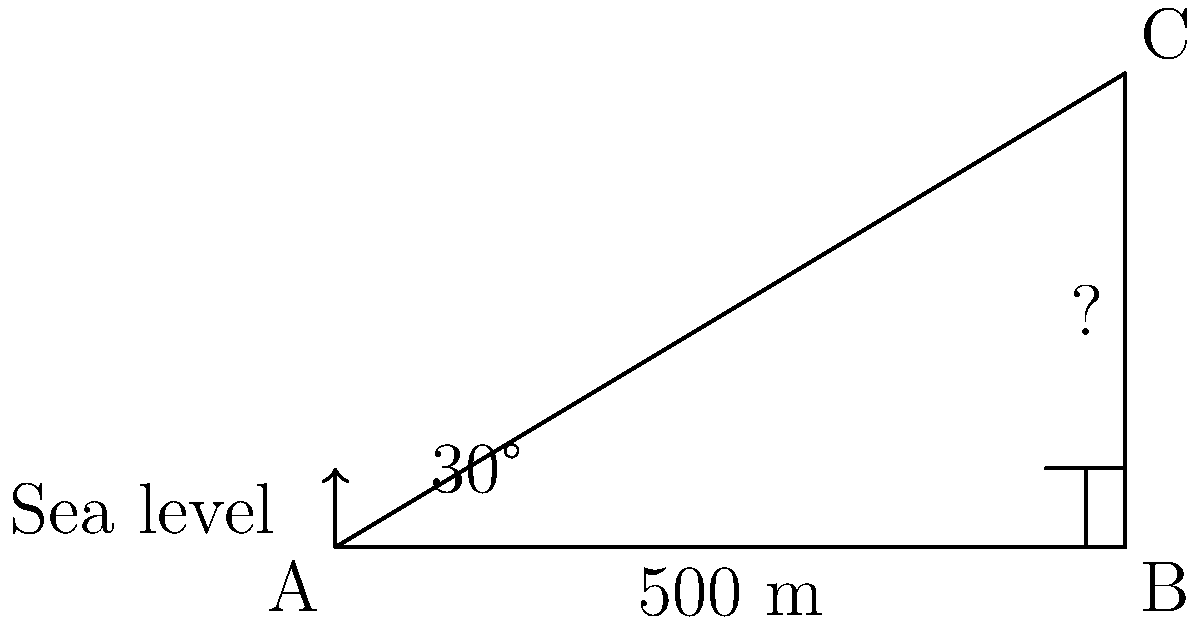As part of your lupus journey, you decide to challenge yourself by climbing a mountain. To prepare for the climb, you want to estimate the mountain's height. From a distance of 500 meters from the base of the mountain, you measure the angle of elevation to the peak to be 30°. Using this information, calculate the height of the mountain. How does this challenge relate to managing lupus? Let's approach this step-by-step, relating each step to managing lupus:

1) First, we identify the given information:
   - Distance from the observer to the base of the mountain: 500 m
   - Angle of elevation: 30°

   This is like gathering information about your lupus symptoms and triggers.

2) We can visualize this as a right-angled triangle, where:
   - The base of the triangle is the distance on the ground (500 m)
   - The height of the triangle is the mountain's height (what we're solving for)
   - The angle at the base is 30°

   This is similar to mapping out your lupus management plan.

3) We need to use the tangent ratio, as we're relating the opposite side (mountain height) to the adjacent side (ground distance):

   $\tan(\theta) = \frac{\text{opposite}}{\text{adjacent}}$

4) Plugging in our values:

   $\tan(30°) = \frac{\text{height}}{500}$

5) We know that $\tan(30°) = \frac{1}{\sqrt{3}}$, so:

   $\frac{1}{\sqrt{3}} = \frac{\text{height}}{500}$

6) Cross multiply:

   $500 \cdot \frac{1}{\sqrt{3}} = \text{height}$

7) Simplify:

   $\text{height} = \frac{500}{\sqrt{3}} \approx 288.68$ meters

This process of breaking down a complex problem into manageable steps is similar to how you might approach managing lupus - taking it one step at a time, using the tools and knowledge available to you.
Answer: $\frac{500}{\sqrt{3}} \approx 288.68$ meters 